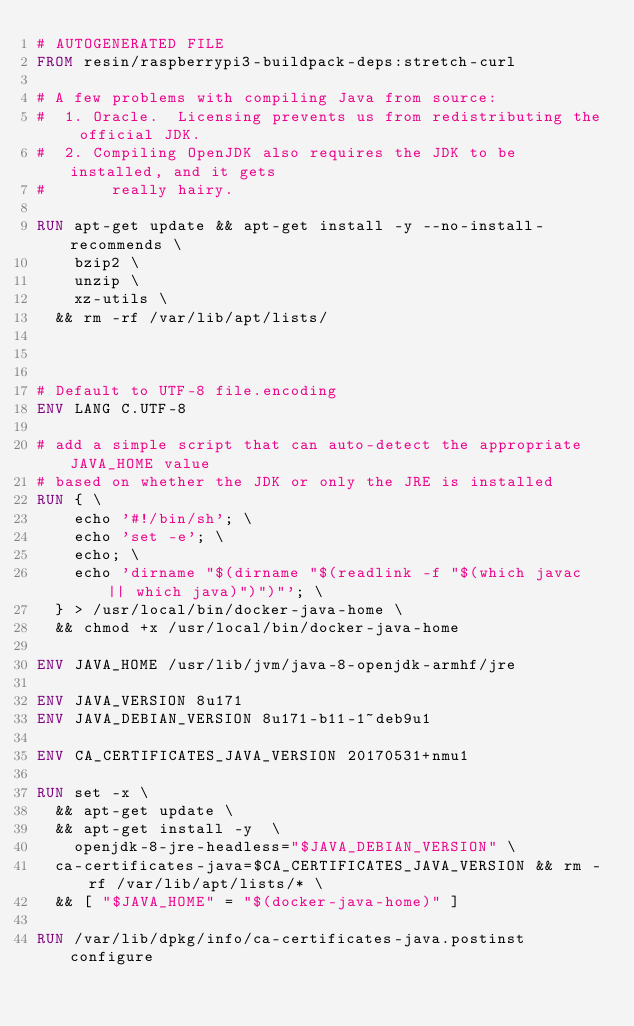Convert code to text. <code><loc_0><loc_0><loc_500><loc_500><_Dockerfile_># AUTOGENERATED FILE
FROM resin/raspberrypi3-buildpack-deps:stretch-curl

# A few problems with compiling Java from source:
#  1. Oracle.  Licensing prevents us from redistributing the official JDK.
#  2. Compiling OpenJDK also requires the JDK to be installed, and it gets
#       really hairy.

RUN apt-get update && apt-get install -y --no-install-recommends \
		bzip2 \
		unzip \
		xz-utils \
	&& rm -rf /var/lib/apt/lists/



# Default to UTF-8 file.encoding
ENV LANG C.UTF-8

# add a simple script that can auto-detect the appropriate JAVA_HOME value
# based on whether the JDK or only the JRE is installed
RUN { \
		echo '#!/bin/sh'; \
		echo 'set -e'; \
		echo; \
		echo 'dirname "$(dirname "$(readlink -f "$(which javac || which java)")")"'; \
	} > /usr/local/bin/docker-java-home \
	&& chmod +x /usr/local/bin/docker-java-home

ENV JAVA_HOME /usr/lib/jvm/java-8-openjdk-armhf/jre

ENV JAVA_VERSION 8u171
ENV JAVA_DEBIAN_VERSION 8u171-b11-1~deb9u1

ENV CA_CERTIFICATES_JAVA_VERSION 20170531+nmu1

RUN set -x \
	&& apt-get update \
	&& apt-get install -y  \
		openjdk-8-jre-headless="$JAVA_DEBIAN_VERSION" \
	ca-certificates-java=$CA_CERTIFICATES_JAVA_VERSION && rm -rf /var/lib/apt/lists/* \
	&& [ "$JAVA_HOME" = "$(docker-java-home)" ]

RUN /var/lib/dpkg/info/ca-certificates-java.postinst configure
</code> 